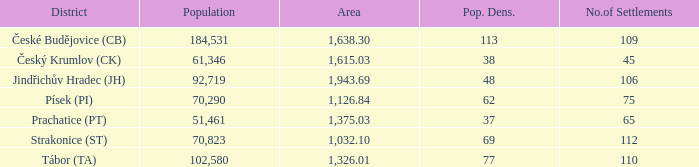What is the extent of the area with a population density of 113 and a population surpassing 184,531? 0.0. 